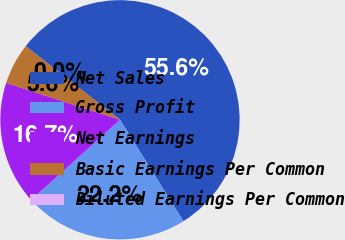<chart> <loc_0><loc_0><loc_500><loc_500><pie_chart><fcel>Net Sales<fcel>Gross Profit<fcel>Net Earnings<fcel>Basic Earnings Per Common<fcel>Diluted Earnings Per Common<nl><fcel>55.55%<fcel>22.22%<fcel>16.67%<fcel>5.56%<fcel>0.0%<nl></chart> 